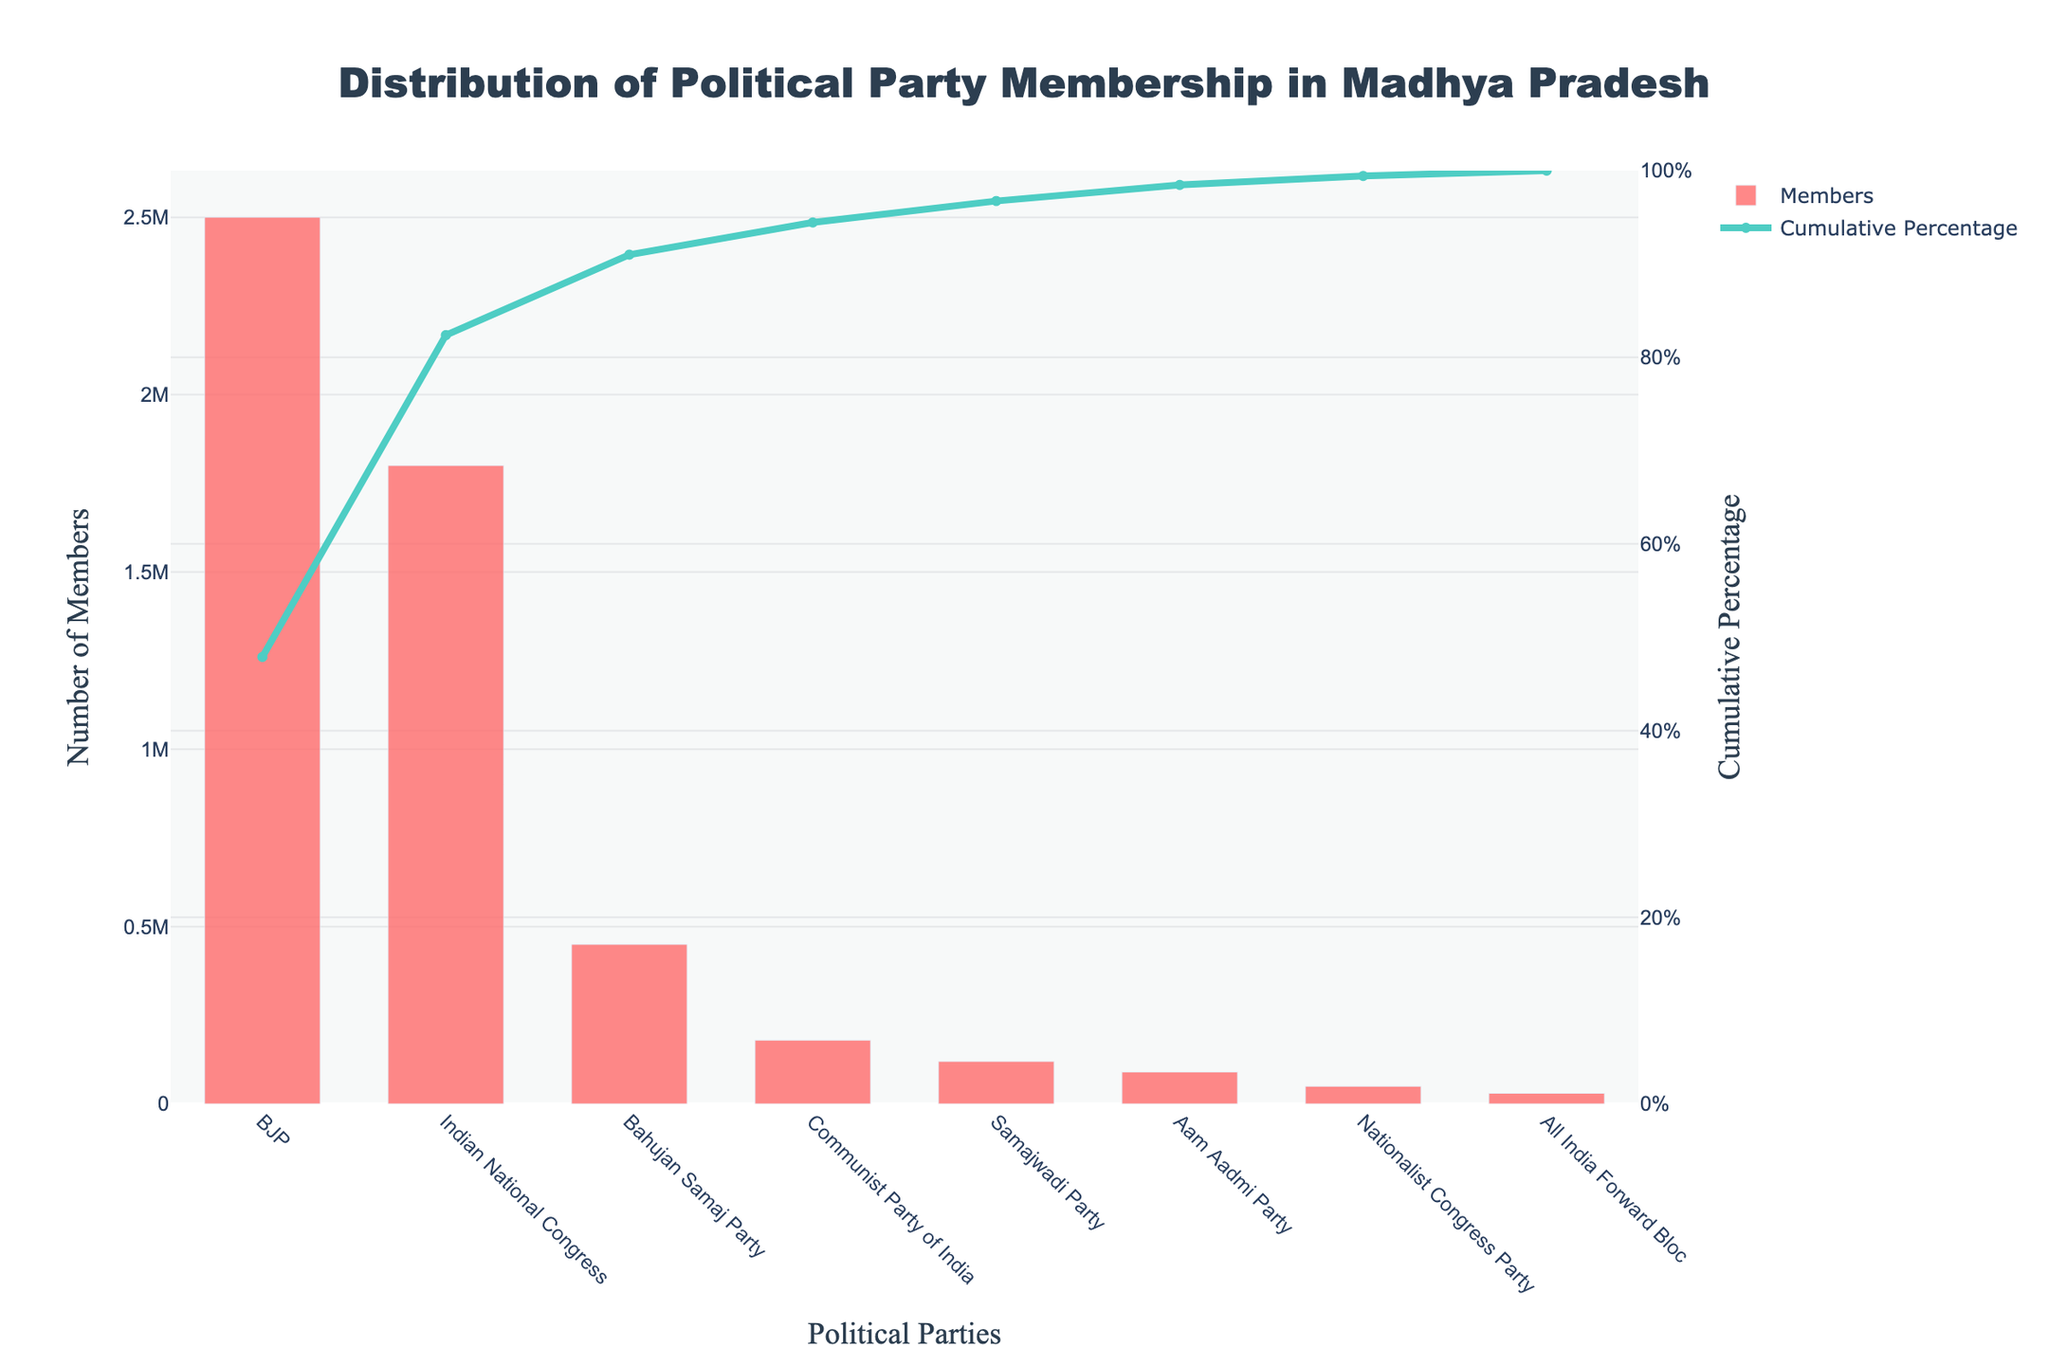What is the political party with the highest membership in Madhya Pradesh? The figure displays a Pareto chart showing the distribution of political party membership. The bar with the highest value represents the BJP.
Answer: BJP What is the cumulative percentage of membership for Indian National Congress, Bahujan Samaj Party, and Communist Party of India combined? Locate the bars for Indian National Congress, Bahujan Samaj Party, and Communist Party of India, identify their cumulative percentage values on the secondary y-axis, and add them together.
Answer: 82.5% Which party marks the first 80% of cumulative membership in the chart? The cumulative percentage line intersects with 80% before reaching the Communists Party of India bar. Thus, all parties up to and including Bahujan Samaj Party contribute to the first 80%.
Answer: Bahujan Samaj Party What is the difference in membership numbers between the BJP and the Samajwadi Party? Find the membership values for BJP (2,500,000) and Samajwadi Party (120,000) and subtract the smaller number from the larger one.
Answer: 2,380,000 How many political parties have less than 100,000 members? Count the bars representing parties that have membership numbers below 100,000 by looking at the y-axis with the number of members.
Answer: Three parties What is the color used for the bars in the chart? Identify the color used for bars by visually inspecting the chart and noting the color.
Answer: Red Which is the smallest party by membership in the Pareto chart? Examine the bar with the smallest height in the chart to determine the party name.
Answer: All India Forward Bloc How much membership does the Bahujan Samaj Party have compared to the Indian National Congress? Divide the membership number of Bahujan Samaj Party (450,000) by that of Indian National Congress (1,800,000) to find the ratio.
Answer: 0.25 or 25% At what cumulative percentage do the top three parties (BJP, Indian National Congress, Bahujan Samaj Party) sum their memberships? Add the cumulative percentages of BJP, Indian National Congress, and Bahujan Samaj Party shown on the secondary y-axis.
Answer: 87.5% Is the total membership contributed by Aam Aadmi Party and Nationalist Congress Party more than 100,000? Add the memberships of Aam Aadmi Party (90,000) and Nationalist Congress Party (50,000) and compare the sum against 100,000.
Answer: Yes 